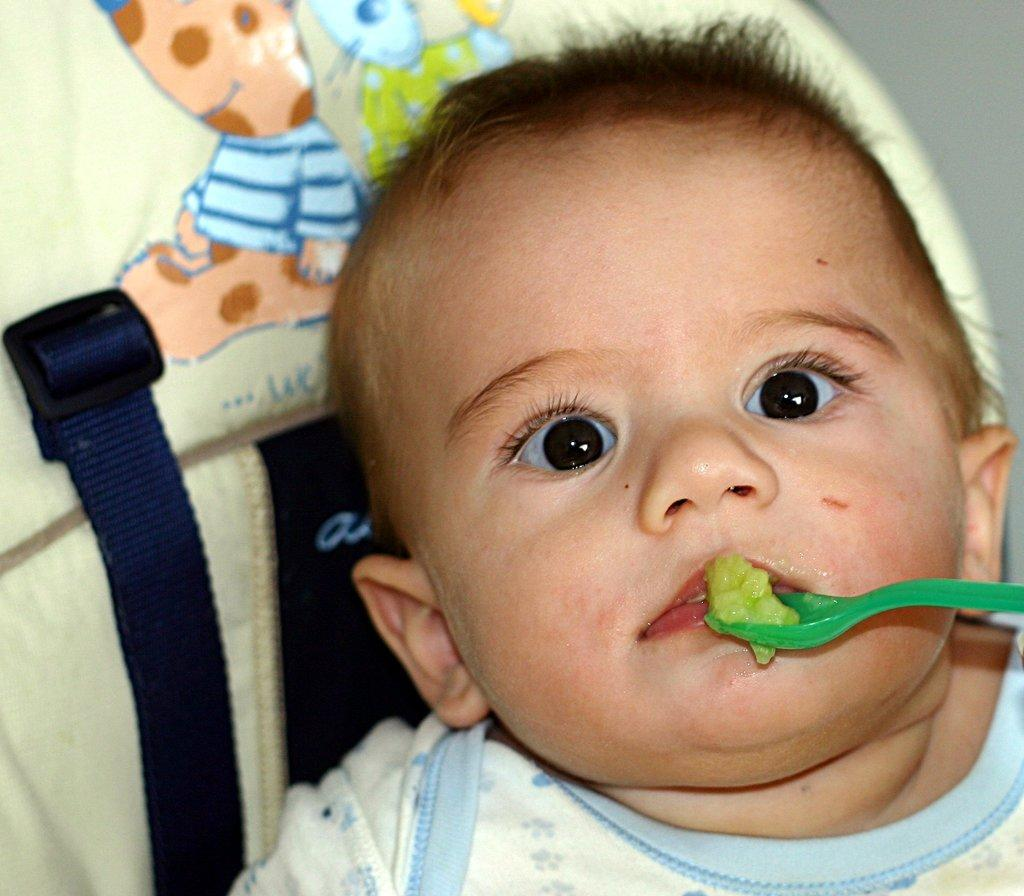What is the main subject of the image? There is a child in the image. What object is associated with the child? There is a spoon in the image. What type of material is present in the image? There is cloth in the image. Can you describe any other objects in the image? There are some unspecified objects in the image. What type of pipe is being used by the child in the image? There is no pipe present in the image. What badge is the child wearing in the image? There is no badge present in the image. 